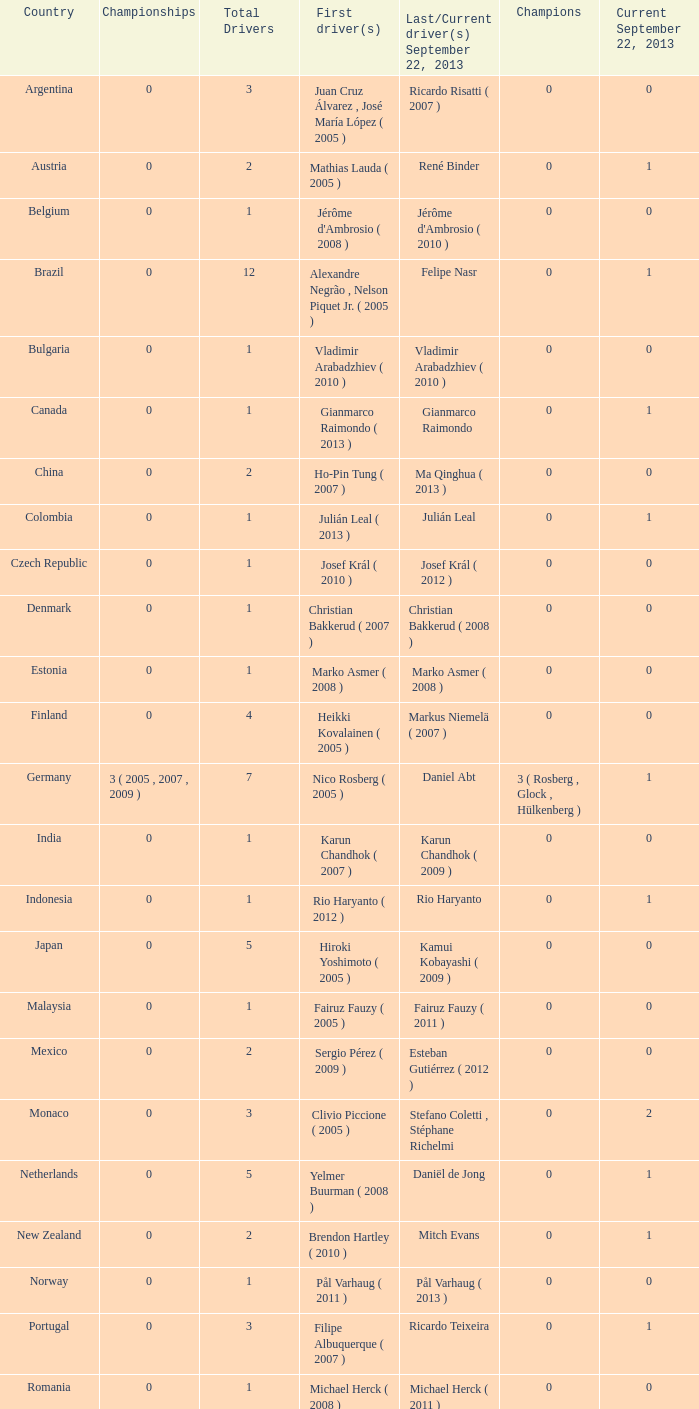When hiroki yoshimoto became the first driver in 2005, what was the number of champions? 0.0. 